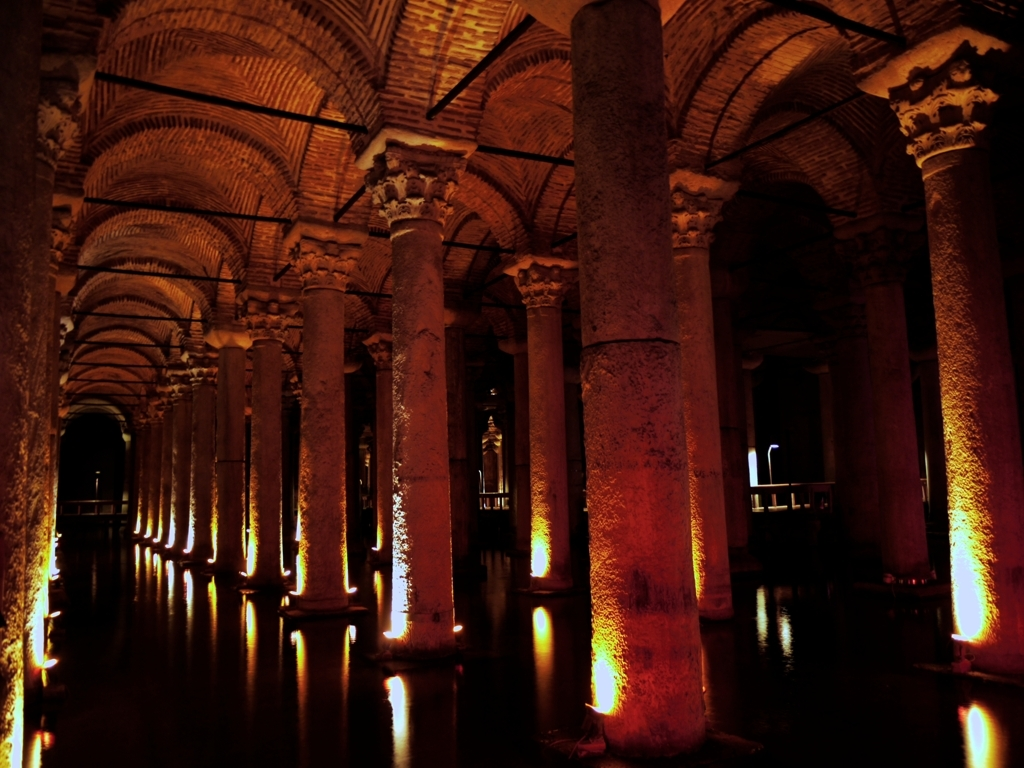Are all the details sharp in the image? The sharpness of details in the image varies. The foreground shows clear details with discernible textures on the pillars and reflections on the water, indicating a well-lit area. As the distance increases, the sharpness drops due to the shadows and lighting, giving a mysterious ambience to the scene. 